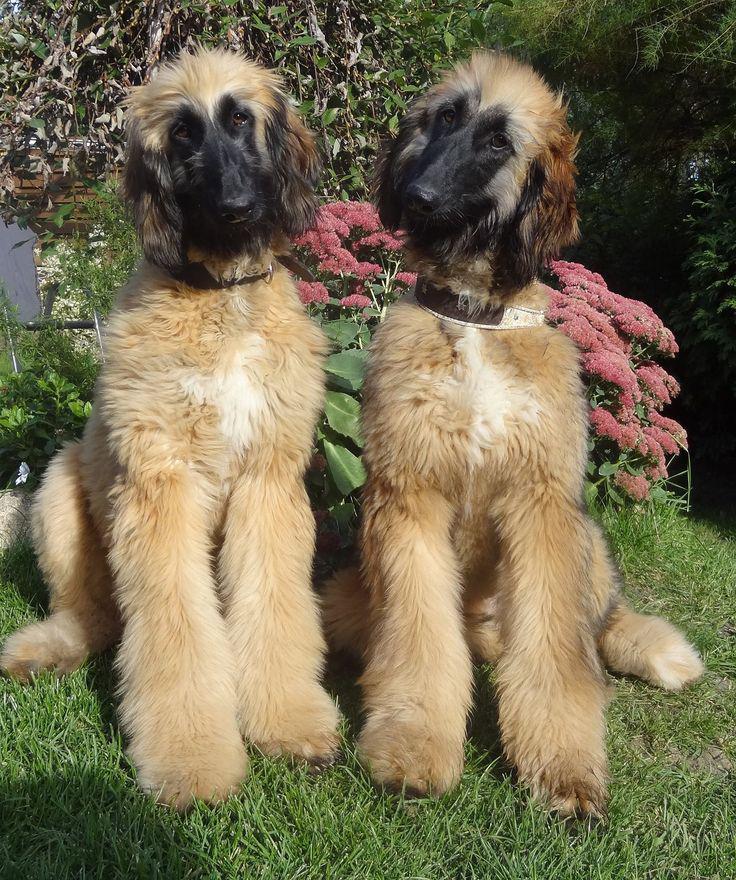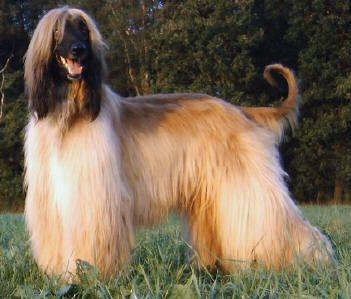The first image is the image on the left, the second image is the image on the right. Evaluate the accuracy of this statement regarding the images: "One photo contains exactly two dogs while the other photo contains only one, and all dogs are photographed outside in grass.". Is it true? Answer yes or no. Yes. The first image is the image on the left, the second image is the image on the right. For the images displayed, is the sentence "There are exactly three dogs in total." factually correct? Answer yes or no. Yes. 